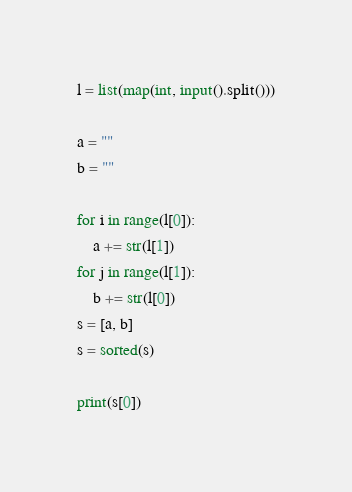<code> <loc_0><loc_0><loc_500><loc_500><_Python_>l = list(map(int, input().split()))

a = ""
b = ""

for i in range(l[0]):
    a += str(l[1])
for j in range(l[1]):
    b += str(l[0])
s = [a, b]
s = sorted(s)

print(s[0])</code> 